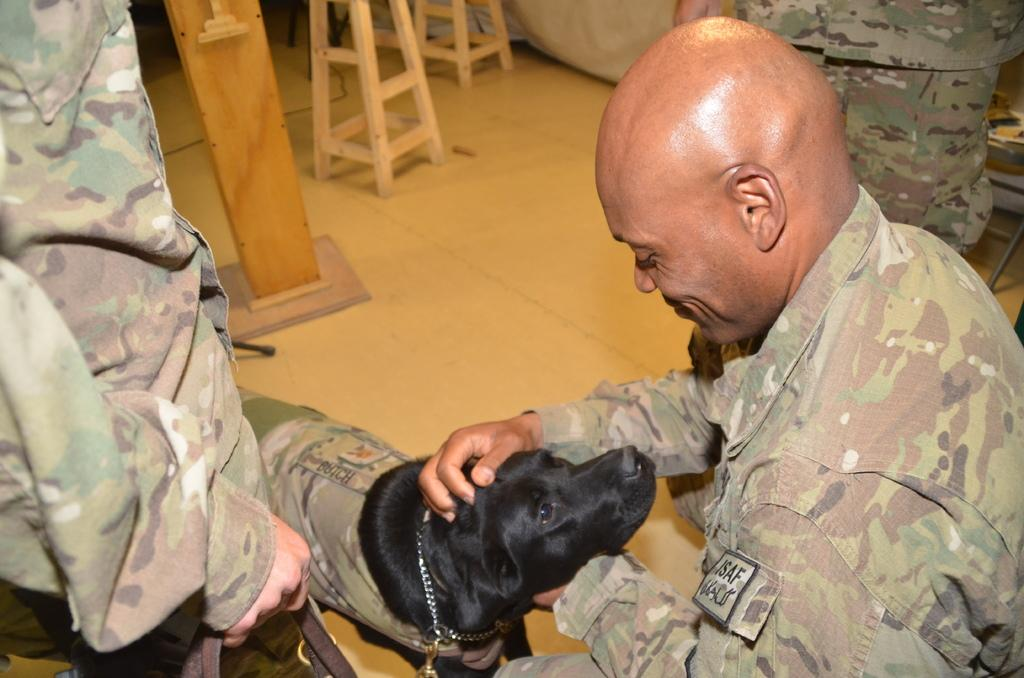Who is the main subject in the image? There is a man in the image. What is the man doing in the image? The man is looking at a black dog. Are there any other people in the image? Yes, there are people in the image. What are the people wearing? The people are wearing military dress. What type of objects can be seen in the image? There are wooden objects in the image. What type of board is the actor using in the image? There is no actor or board present in the image. What type of yoke is visible in the image? There is no yoke visible in the image. 